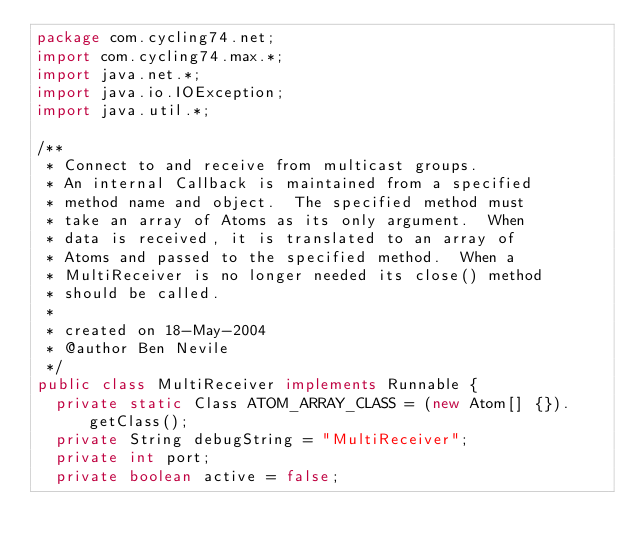Convert code to text. <code><loc_0><loc_0><loc_500><loc_500><_Java_>package com.cycling74.net;
import com.cycling74.max.*;
import java.net.*;
import java.io.IOException;
import java.util.*;

/**
 * Connect to and receive from multicast groups.  
 * An internal Callback is maintained from a specified 
 * method name and object.  The specified method must 
 * take an array of Atoms as its only argument.  When
 * data is received, it is translated to an array of
 * Atoms and passed to the specified method.  When a
 * MultiReceiver is no longer needed its close() method 
 * should be called.
 * 
 * created on 18-May-2004
 * @author Ben Nevile
 */
public class MultiReceiver implements Runnable {
	private static Class ATOM_ARRAY_CLASS = (new Atom[] {}).getClass();
	private String debugString = "MultiReceiver";
	private int port;
	private boolean active = false;
</code> 